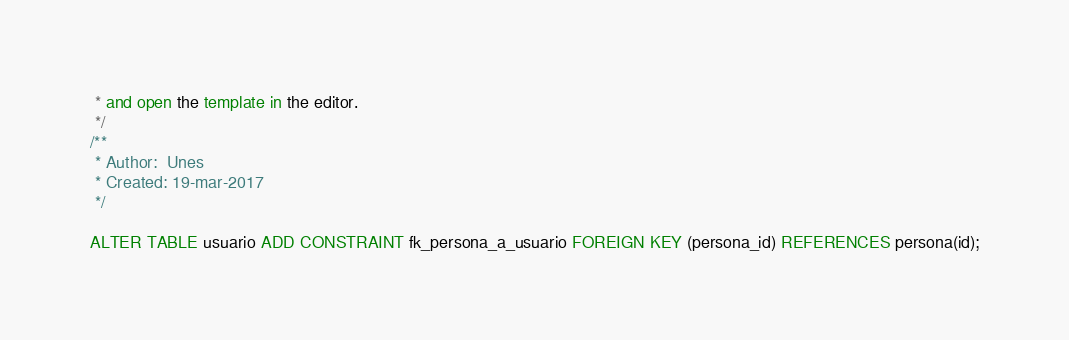Convert code to text. <code><loc_0><loc_0><loc_500><loc_500><_SQL_> * and open the template in the editor.
 */
/**
 * Author:  Unes
 * Created: 19-mar-2017
 */

ALTER TABLE usuario ADD CONSTRAINT fk_persona_a_usuario FOREIGN KEY (persona_id) REFERENCES persona(id);</code> 